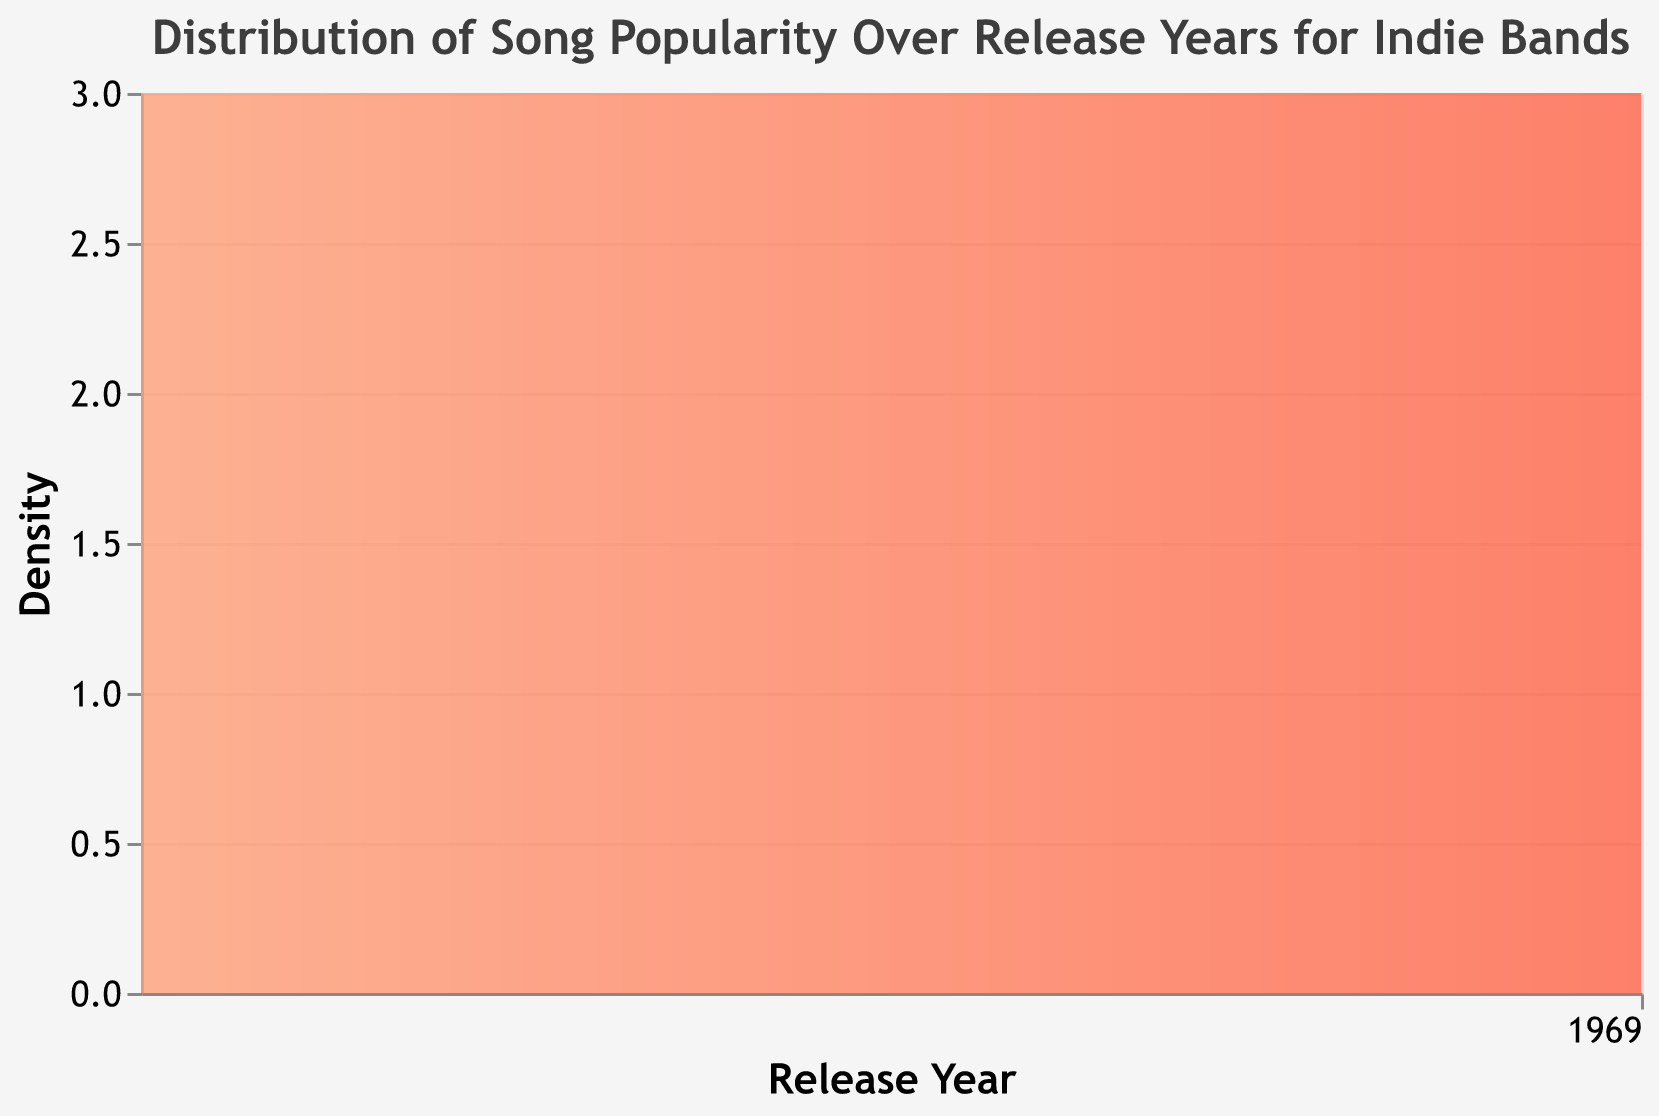What's the title of the plot? The title is typically displayed at the top of the plot, summarizing what the visualization represents. The title here is "Distribution of Song Popularity Over Release Years for Indie Bands."
Answer: Distribution of Song Popularity Over Release Years for Indie Bands What colors are used in the gradient of the density plot? The gradient colors can be seen by observing the shaded area of the density plot. The colors used range from light orange at the beginning to red at the end.
Answer: Light orange to red Which release year has the most songs included in the plot? Observing the peaks in the density plot can help determine which year has the highest density. The tallest peak in the plot corresponds to the year with the most songs.
Answer: 2023 How many songs were released in 2020 according to the plot? To find the density or count of songs for 2020, look at where the plot has points aligned vertically under the year 2020 on the x-axis. The height of the area plot indicates the count.
Answer: 3 Describe the trend of song popularity distribution from 2018 to 2023. Observing the plot from left (2018) to right (2023), you can see how the density changes over time, with a gradual increase in density, particularly peaking around 2023. This suggests more songs being released towards later years.
Answer: Increasing trend with peaks in 2020 and 2023 Compare the song densities between 2018 and 2021. Which year has a higher density? Comparing the heights of the area for 2018 and 2021, 2021 has a much higher peak. This indicates a higher density or more songs in that year.
Answer: 2021 What might be inferred about the popularity of indie bands over the provided years? Given the increasing density in latter years, it can be inferred that the popularity and perhaps the number of releases by indie bands have increased over time. The continuous rise in the plot signifies more releases and possibly higher popularity.
Answer: Increasing popularity and releases over time What's the average density of songs released in 2019 and 2022? To calculate the average density for two years, sum the densities (or count) for 2019 and 2022, then divide by 2. From the plot, 2019 has 3 songs and 2022 has 3 songs. Average = (3+3)/2.
Answer: 3 Which year has the second lowest number of song releases? By observing each year's peak and comparing their heights, the second lowest peak after 2018 is in 2019.
Answer: 2019 How does the distribution change from 2020 to 2021? By comparing the area under the curve for 2020 and 2021, the plot shows a significant rise in density moving from 2020 to 2021, indicating more songs released in 2021.
Answer: Increase in density 